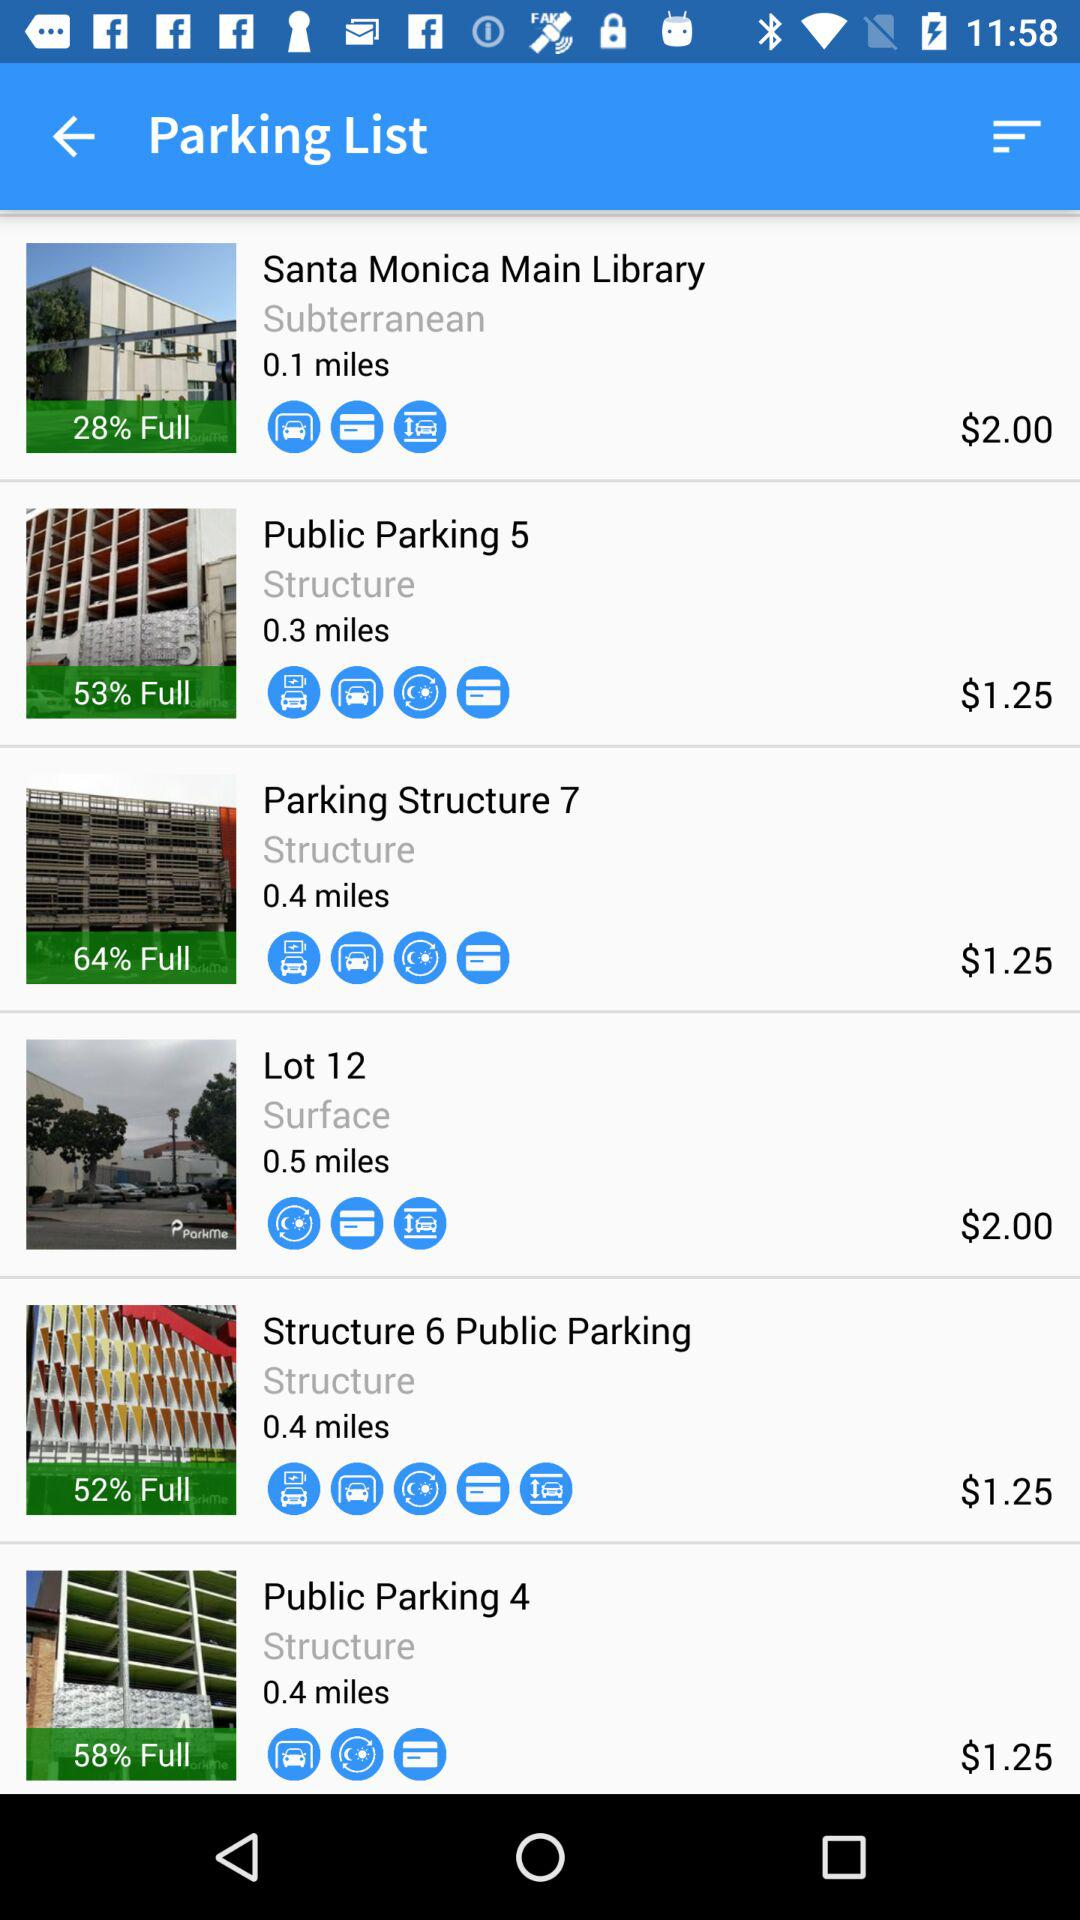How many structures are there with a price of $2.00?
Answer the question using a single word or phrase. 2 